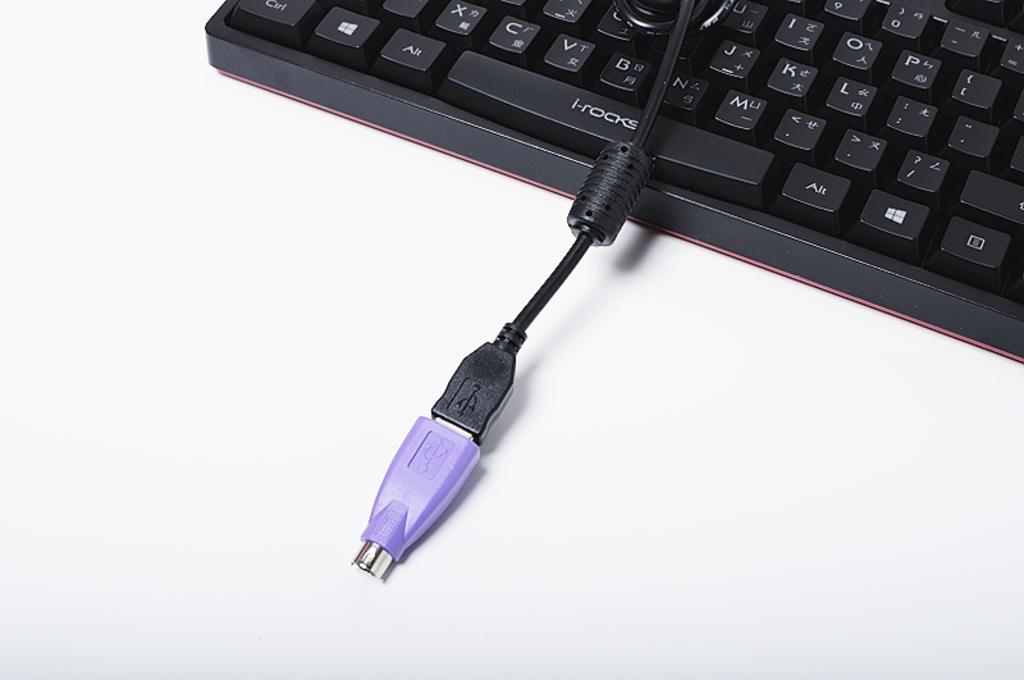What is written on the spacebar of the keyboard?
Your answer should be very brief. I-rocks. What´s the letter on left of the m?
Your answer should be compact. N. 